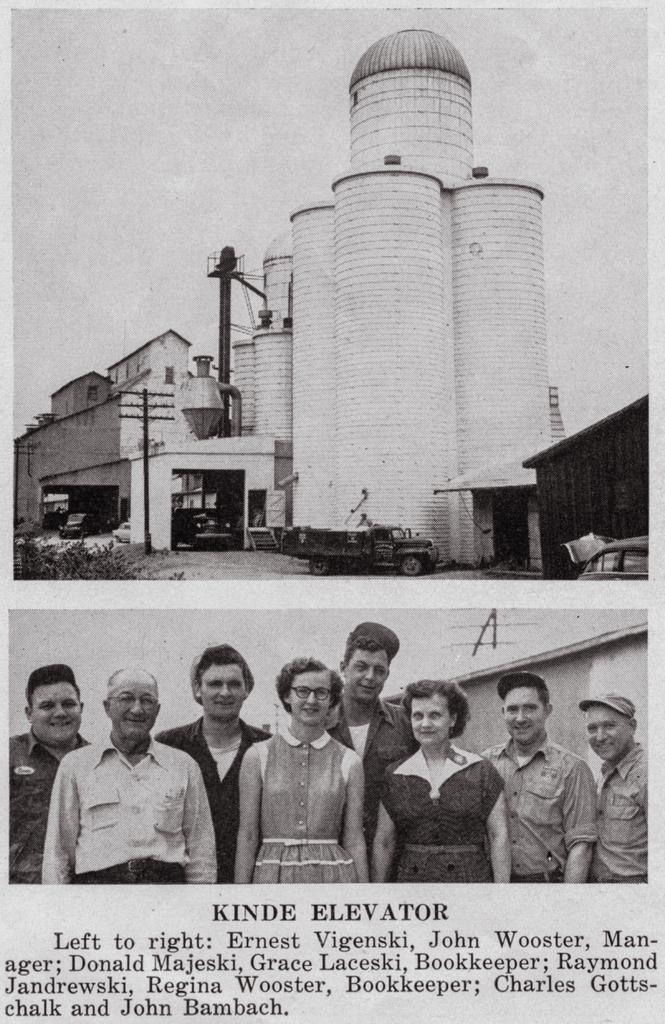What is the main subject of focus of the poster? The main focus of the poster is a group of people. What else can be seen in the background of the poster? There is a building depicted on the poster, along with vehicles, plants, and objects. Is there any text on the poster? Yes, there is text on the poster. What type of cloth is being used to cover the bulb in the image? There is no bulb or cloth present in the image; the focus is on the group of people, building, vehicles, plants, objects, and text on the poster. 